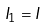<formula> <loc_0><loc_0><loc_500><loc_500>I _ { 1 } = I</formula> 